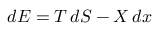Convert formula to latex. <formula><loc_0><loc_0><loc_500><loc_500>d E = T \, d S - X \, d x</formula> 